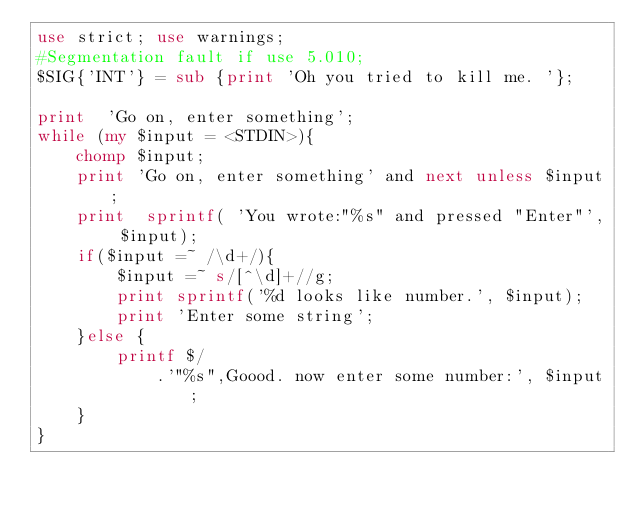<code> <loc_0><loc_0><loc_500><loc_500><_Perl_>use strict; use warnings; 
#Segmentation fault if use 5.010;
$SIG{'INT'} = sub {print 'Oh you tried to kill me. '};

print  'Go on, enter something';
while (my $input = <STDIN>){
    chomp $input;
    print 'Go on, enter something' and next unless $input;
    print  sprintf( 'You wrote:"%s" and pressed "Enter"', $input);
    if($input =~ /\d+/){
        $input =~ s/[^\d]+//g;
        print sprintf('%d looks like number.', $input);
        print 'Enter some string';
    }else {
        printf $/
            .'"%s",Goood. now enter some number:', $input;
    } 
}</code> 